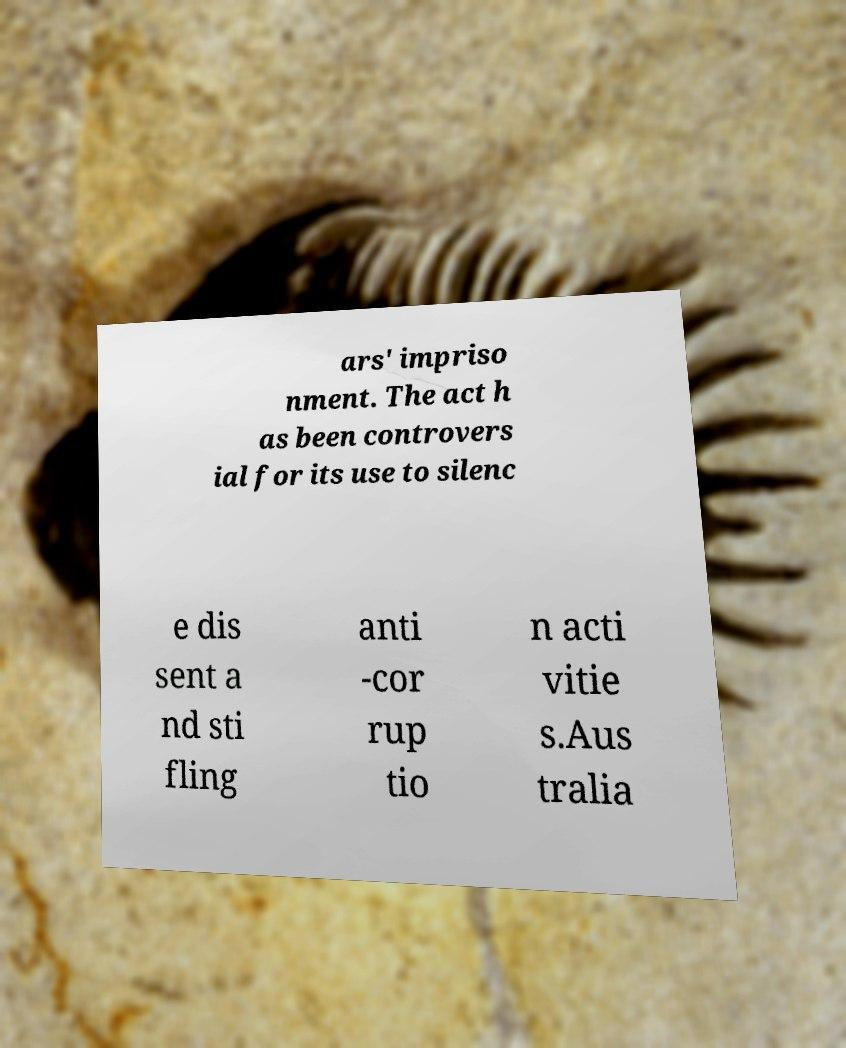Could you extract and type out the text from this image? ars' impriso nment. The act h as been controvers ial for its use to silenc e dis sent a nd sti fling anti -cor rup tio n acti vitie s.Aus tralia 